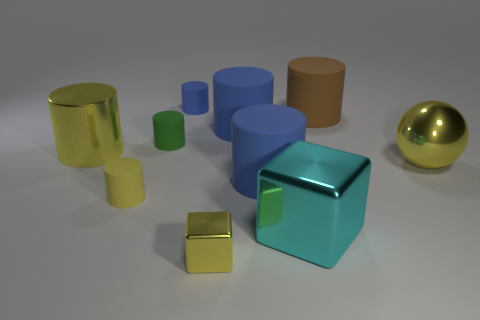Subtract all blue cylinders. How many were subtracted if there are1blue cylinders left? 2 Subtract all yellow cylinders. How many cylinders are left? 5 Subtract all brown cubes. How many yellow cylinders are left? 2 Subtract 3 cylinders. How many cylinders are left? 4 Subtract all yellow cylinders. How many cylinders are left? 5 Add 6 big brown matte balls. How many big brown matte balls exist? 6 Subtract 0 red cubes. How many objects are left? 10 Subtract all spheres. How many objects are left? 9 Subtract all green cylinders. Subtract all blue spheres. How many cylinders are left? 6 Subtract all small shiny things. Subtract all small blue cylinders. How many objects are left? 8 